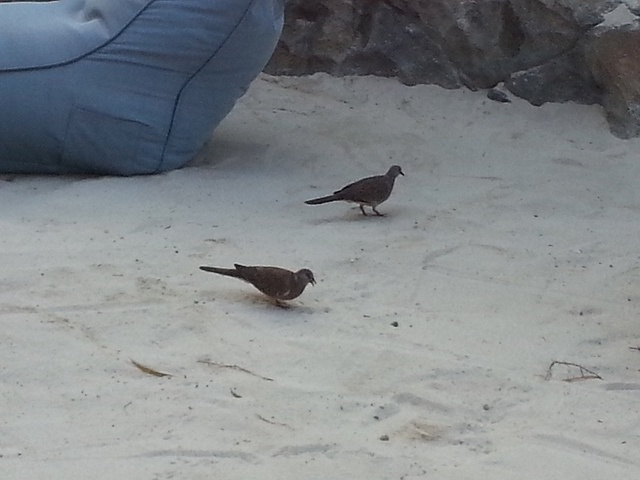Describe the objects in this image and their specific colors. I can see bird in black, gray, and darkgray tones and bird in black and gray tones in this image. 